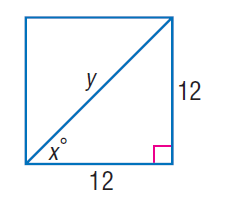Answer the mathemtical geometry problem and directly provide the correct option letter.
Question: Find x.
Choices: A: 30 B: 45 C: 60 D: 90 B 